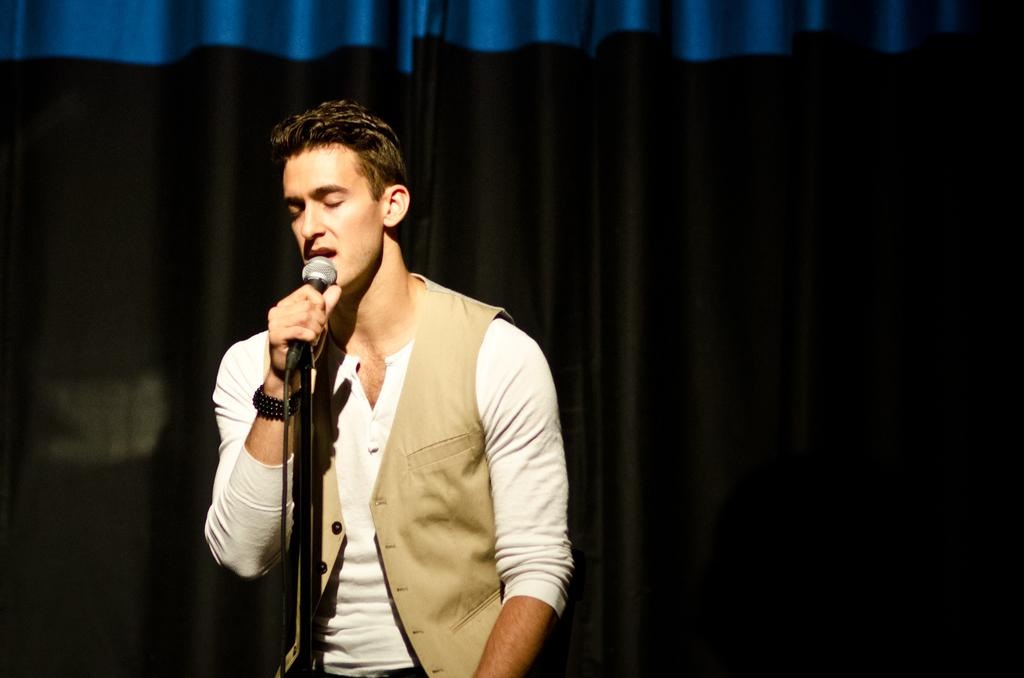What is the person in the image doing? The person is holding a microphone and singing into it. What object is the person holding in the image? The person is holding a microphone. What can be seen in the background of the image? There is a curtain in the image. What type of fruit can be seen hanging from the microphone in the image? There is no fruit hanging from the microphone in the image. 